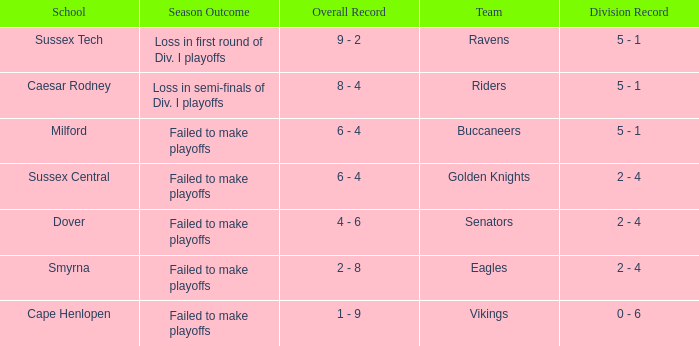What is the Overall Record for the School in Milford? 6 - 4. 